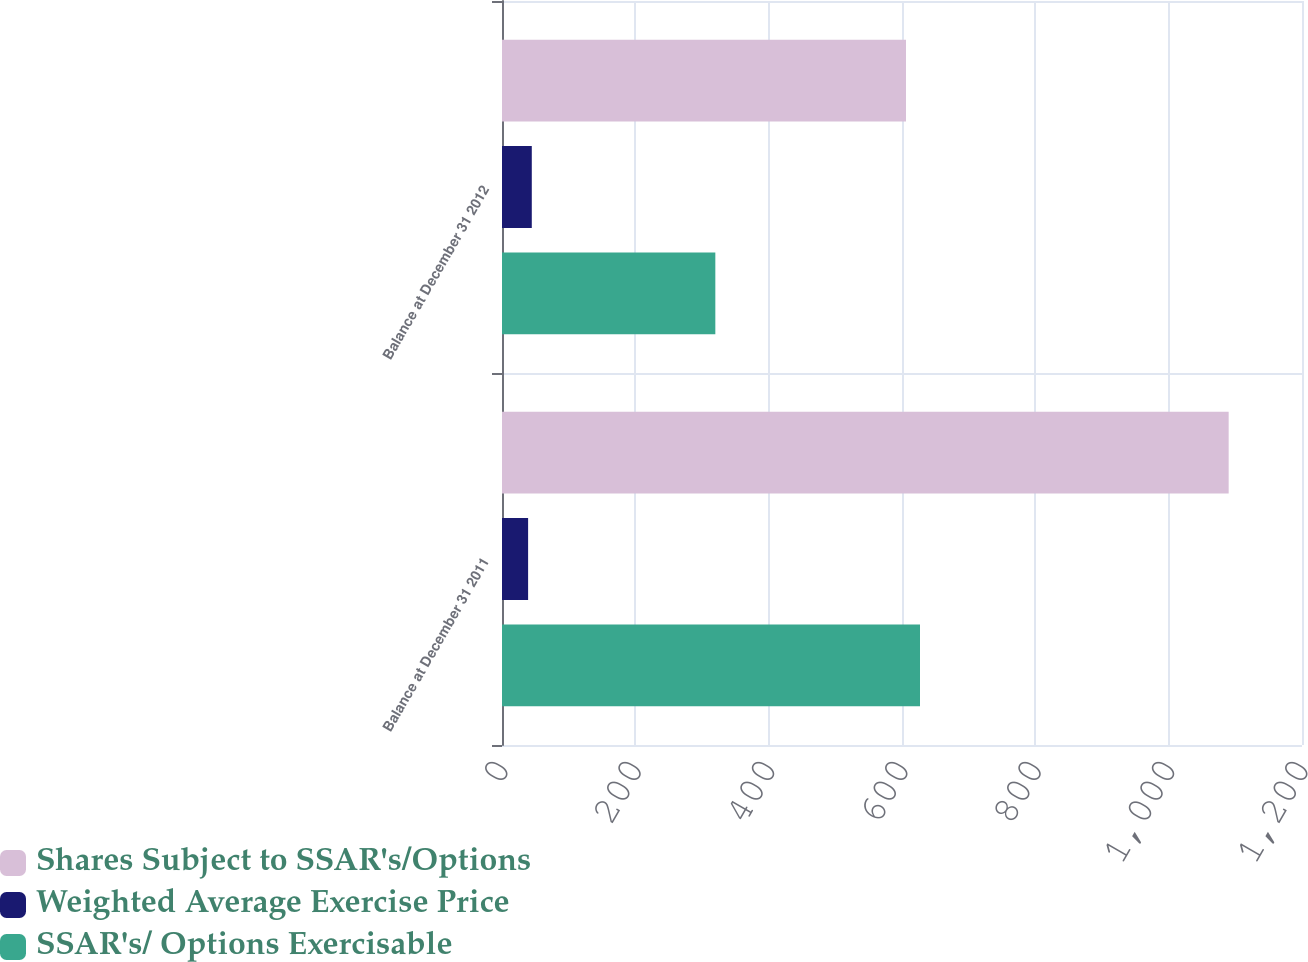Convert chart. <chart><loc_0><loc_0><loc_500><loc_500><stacked_bar_chart><ecel><fcel>Balance at December 31 2011<fcel>Balance at December 31 2012<nl><fcel>Shares Subject to SSAR's/Options<fcel>1090<fcel>606<nl><fcel>Weighted Average Exercise Price<fcel>39.16<fcel>44.68<nl><fcel>SSAR's/ Options Exercisable<fcel>627<fcel>320<nl></chart> 